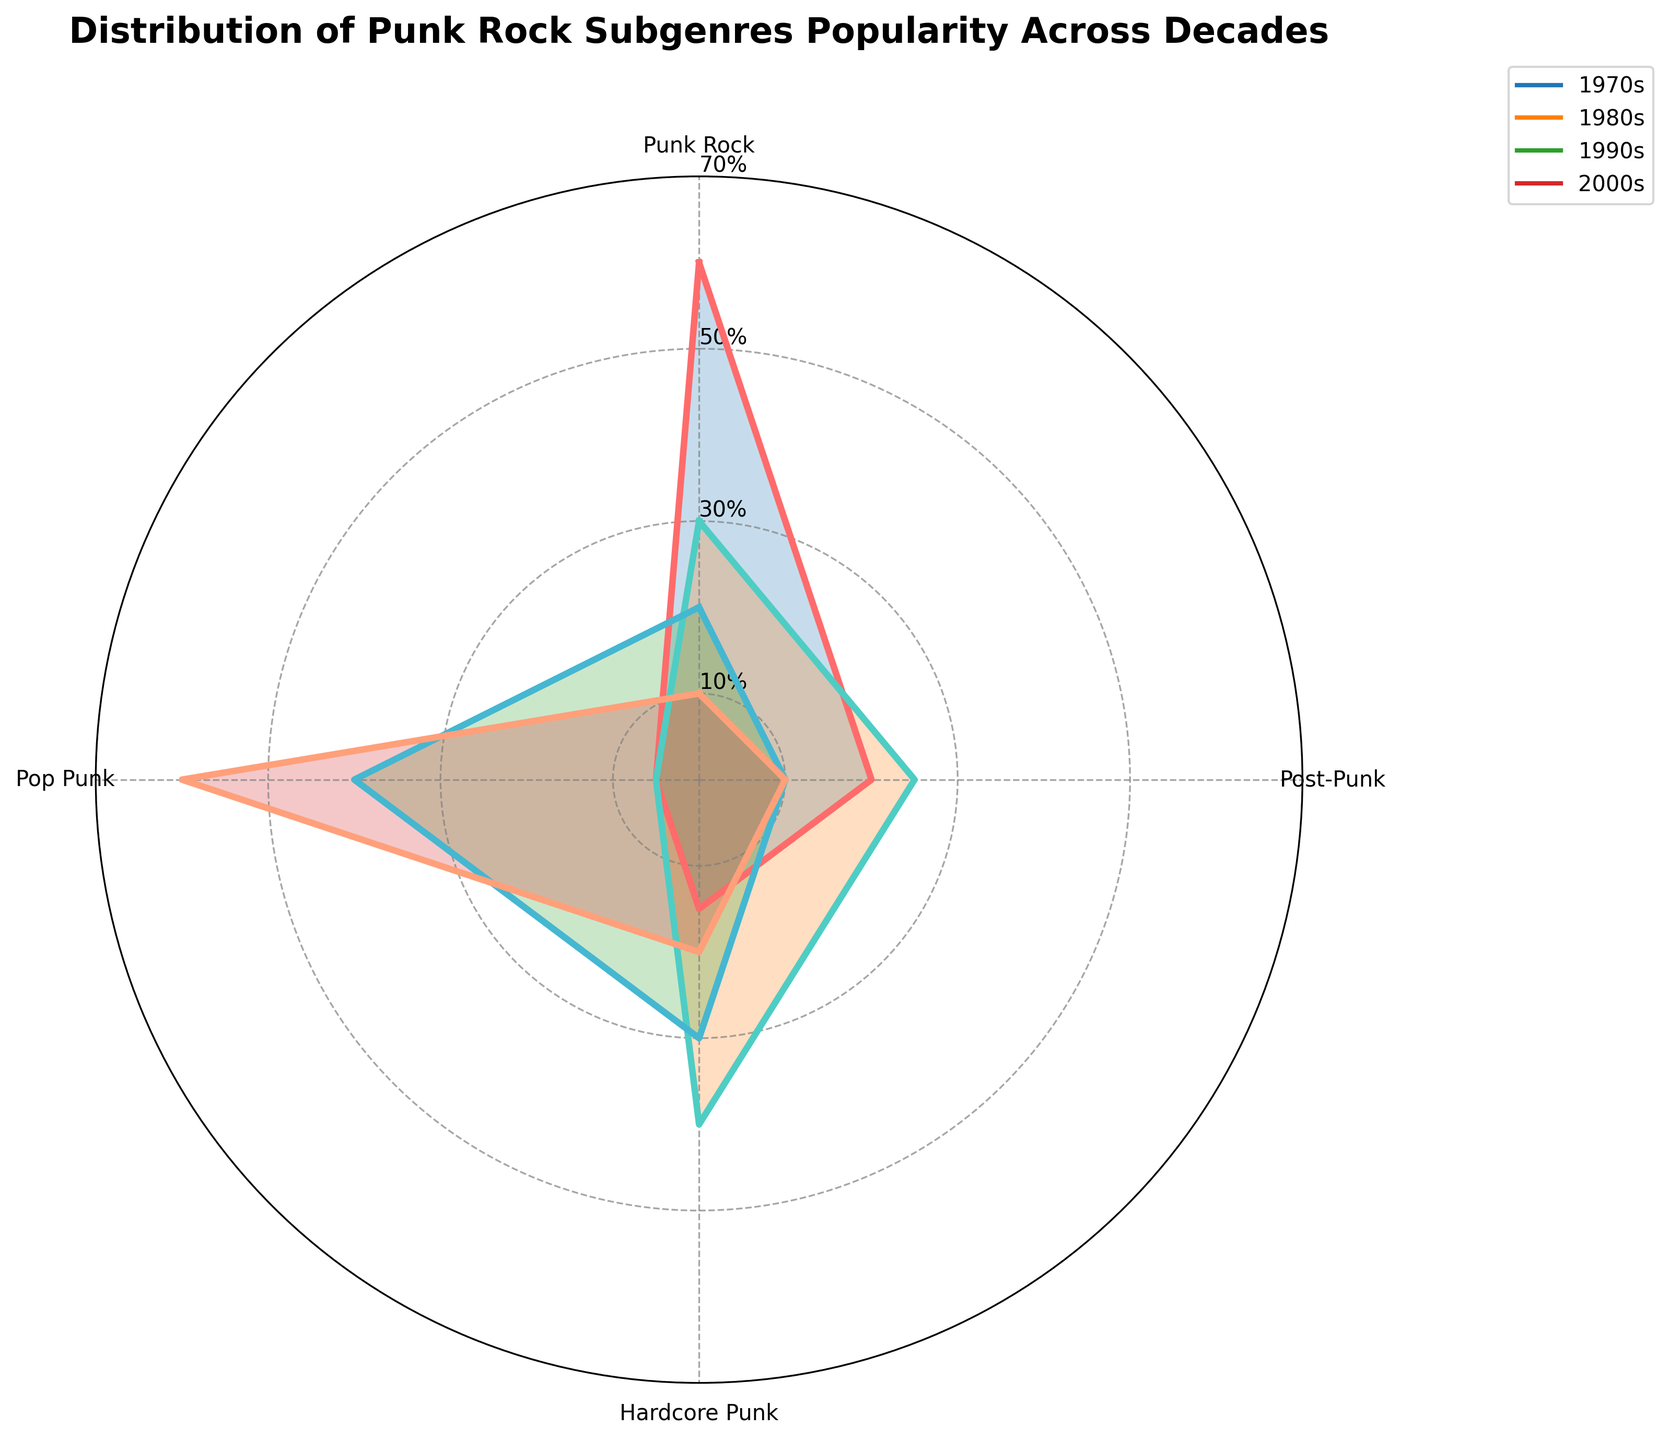What is the title of the radar chart? The title of the radar chart is prominently displayed at the top.
Answer: Distribution of Punk Rock Subgenres Popularity Across Decades How many punk rock subgenres are analyzed in the radar chart? The radar chart features points for different subgenres. Count these points to find the total number of subgenres.
Answer: Four Which decade has the highest popularity for Pop Punk? Look at the radar chart and identify the decade with the greatest reach on the Pop Punk axis.
Answer: 2000s Which subgenre was most popular in the 1970s? On the radar chart, observe the points representing the 1970s. Identify the highest value.
Answer: Punk Rock Between the 1980s and 1990s, which decade saw greater Hardcore Punk popularity? Compare the values for Hardcore Punk in the 1980s and 1990s from the chart.
Answer: 1980s How does Punk Rock popularity change from the 1970s to the 2000s? Trace the values of Punk Rock from the 1970s to the 2000s on the radar chart.
Answer: It decreases every decade Which decade had the least popularity for Post-Punk? Identify the decade with the lowest value on the Post-Punk axis in the radar chart.
Answer: 1990s Calculate the average popularity of Hardcore Punk across the decades. Sum the Hardcore Punk popularity values for each decade and divide by the number of decades: (15 + 40 + 30 + 20) / 4.
Answer: 26.25 How does the popularity of Punk Rock in the 1980s compare to the 1990s? Look at the radar chart and compare the values for Punk Rock in the 1980s and 1990s.
Answer: Higher in the 1980s Which subgenre showed steady popularity (no decrease) across all decades? Look for a subgenre that either remained the same or increased in value across the decades.
Answer: Pop Punk 